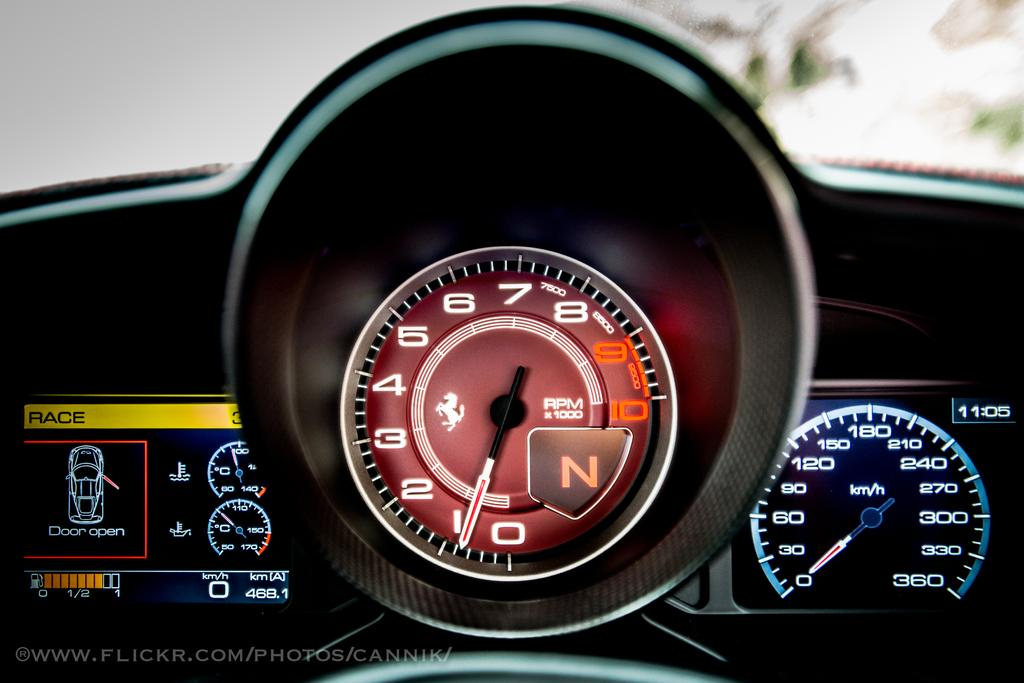What can be seen on the dashboard of the car in the image? The speedometer of the car is visible in the image. What colors are present on the speedometer? The speedometer has black, red, yellow, and blue colors. What is visible in the background of the image? There is a sky and a tree visible in the background of the image. What is the purpose of the aunt in the image? There is no aunt present in the image; it only features a car with a visible speedometer and a background with a sky and a tree. 